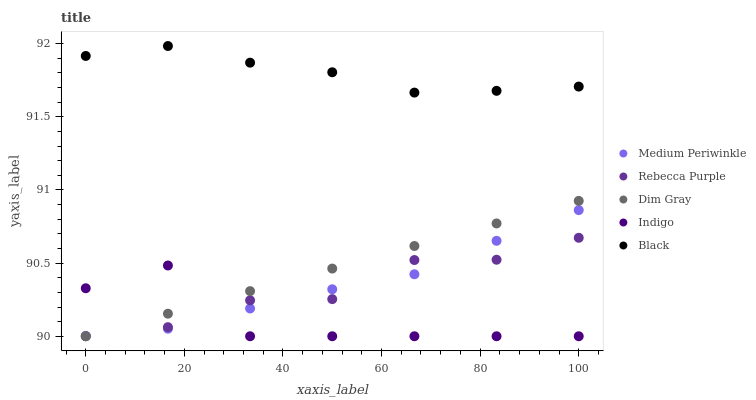Does Indigo have the minimum area under the curve?
Answer yes or no. Yes. Does Black have the maximum area under the curve?
Answer yes or no. Yes. Does Dim Gray have the minimum area under the curve?
Answer yes or no. No. Does Dim Gray have the maximum area under the curve?
Answer yes or no. No. Is Dim Gray the smoothest?
Answer yes or no. Yes. Is Indigo the roughest?
Answer yes or no. Yes. Is Medium Periwinkle the smoothest?
Answer yes or no. No. Is Medium Periwinkle the roughest?
Answer yes or no. No. Does Indigo have the lowest value?
Answer yes or no. Yes. Does Medium Periwinkle have the lowest value?
Answer yes or no. No. Does Black have the highest value?
Answer yes or no. Yes. Does Dim Gray have the highest value?
Answer yes or no. No. Is Indigo less than Black?
Answer yes or no. Yes. Is Black greater than Dim Gray?
Answer yes or no. Yes. Does Medium Periwinkle intersect Dim Gray?
Answer yes or no. Yes. Is Medium Periwinkle less than Dim Gray?
Answer yes or no. No. Is Medium Periwinkle greater than Dim Gray?
Answer yes or no. No. Does Indigo intersect Black?
Answer yes or no. No. 